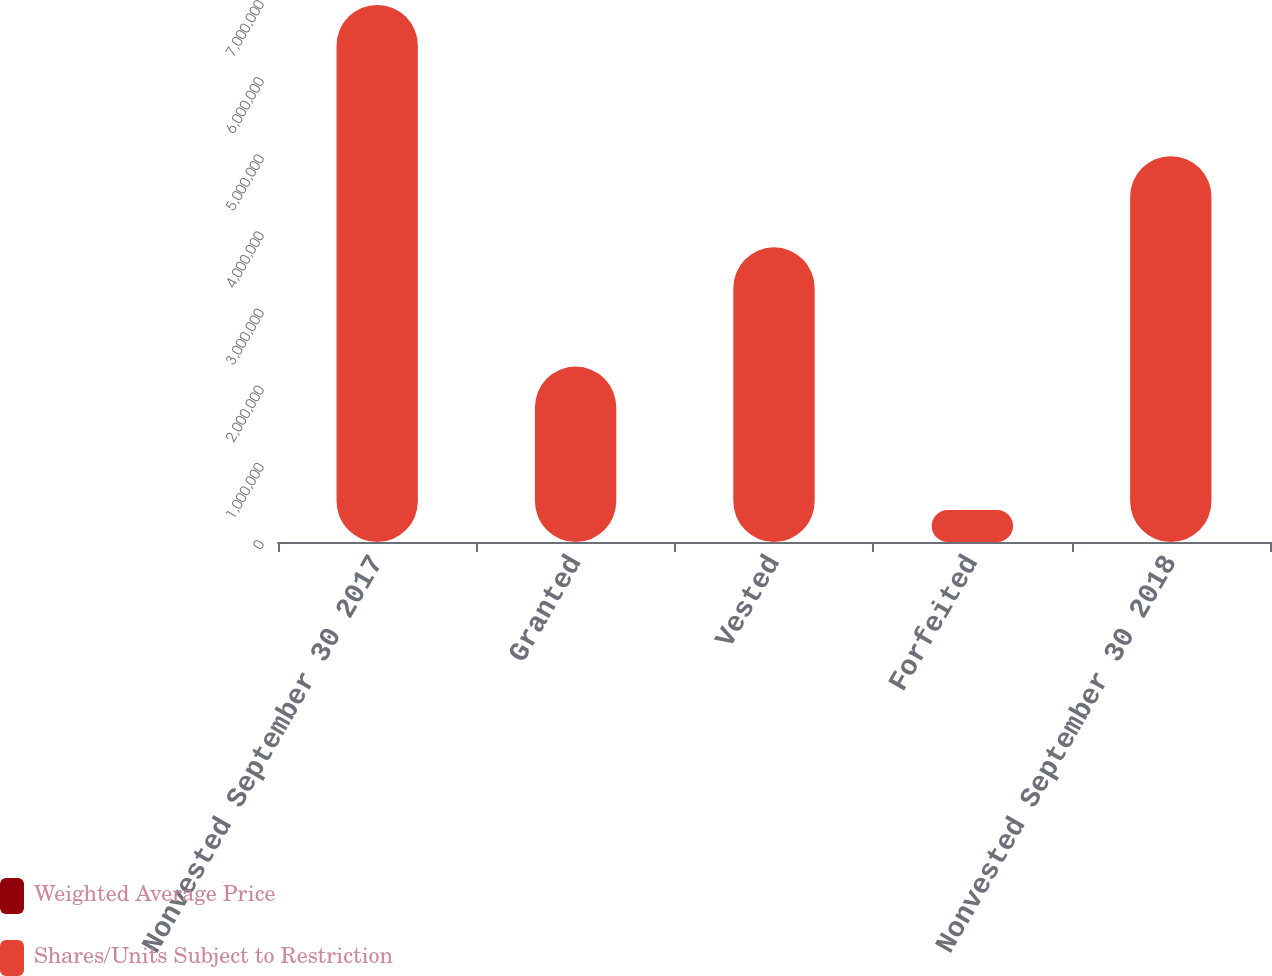Convert chart to OTSL. <chart><loc_0><loc_0><loc_500><loc_500><stacked_bar_chart><ecel><fcel>Nonvested September 30 2017<fcel>Granted<fcel>Vested<fcel>Forfeited<fcel>Nonvested September 30 2018<nl><fcel>Weighted Average Price<fcel>44.48<fcel>37.21<fcel>39.84<fcel>39.38<fcel>45.14<nl><fcel>Shares/Units Subject to Restriction<fcel>6.96171e+06<fcel>2.27416e+06<fcel>3.81958e+06<fcel>414768<fcel>5.00152e+06<nl></chart> 